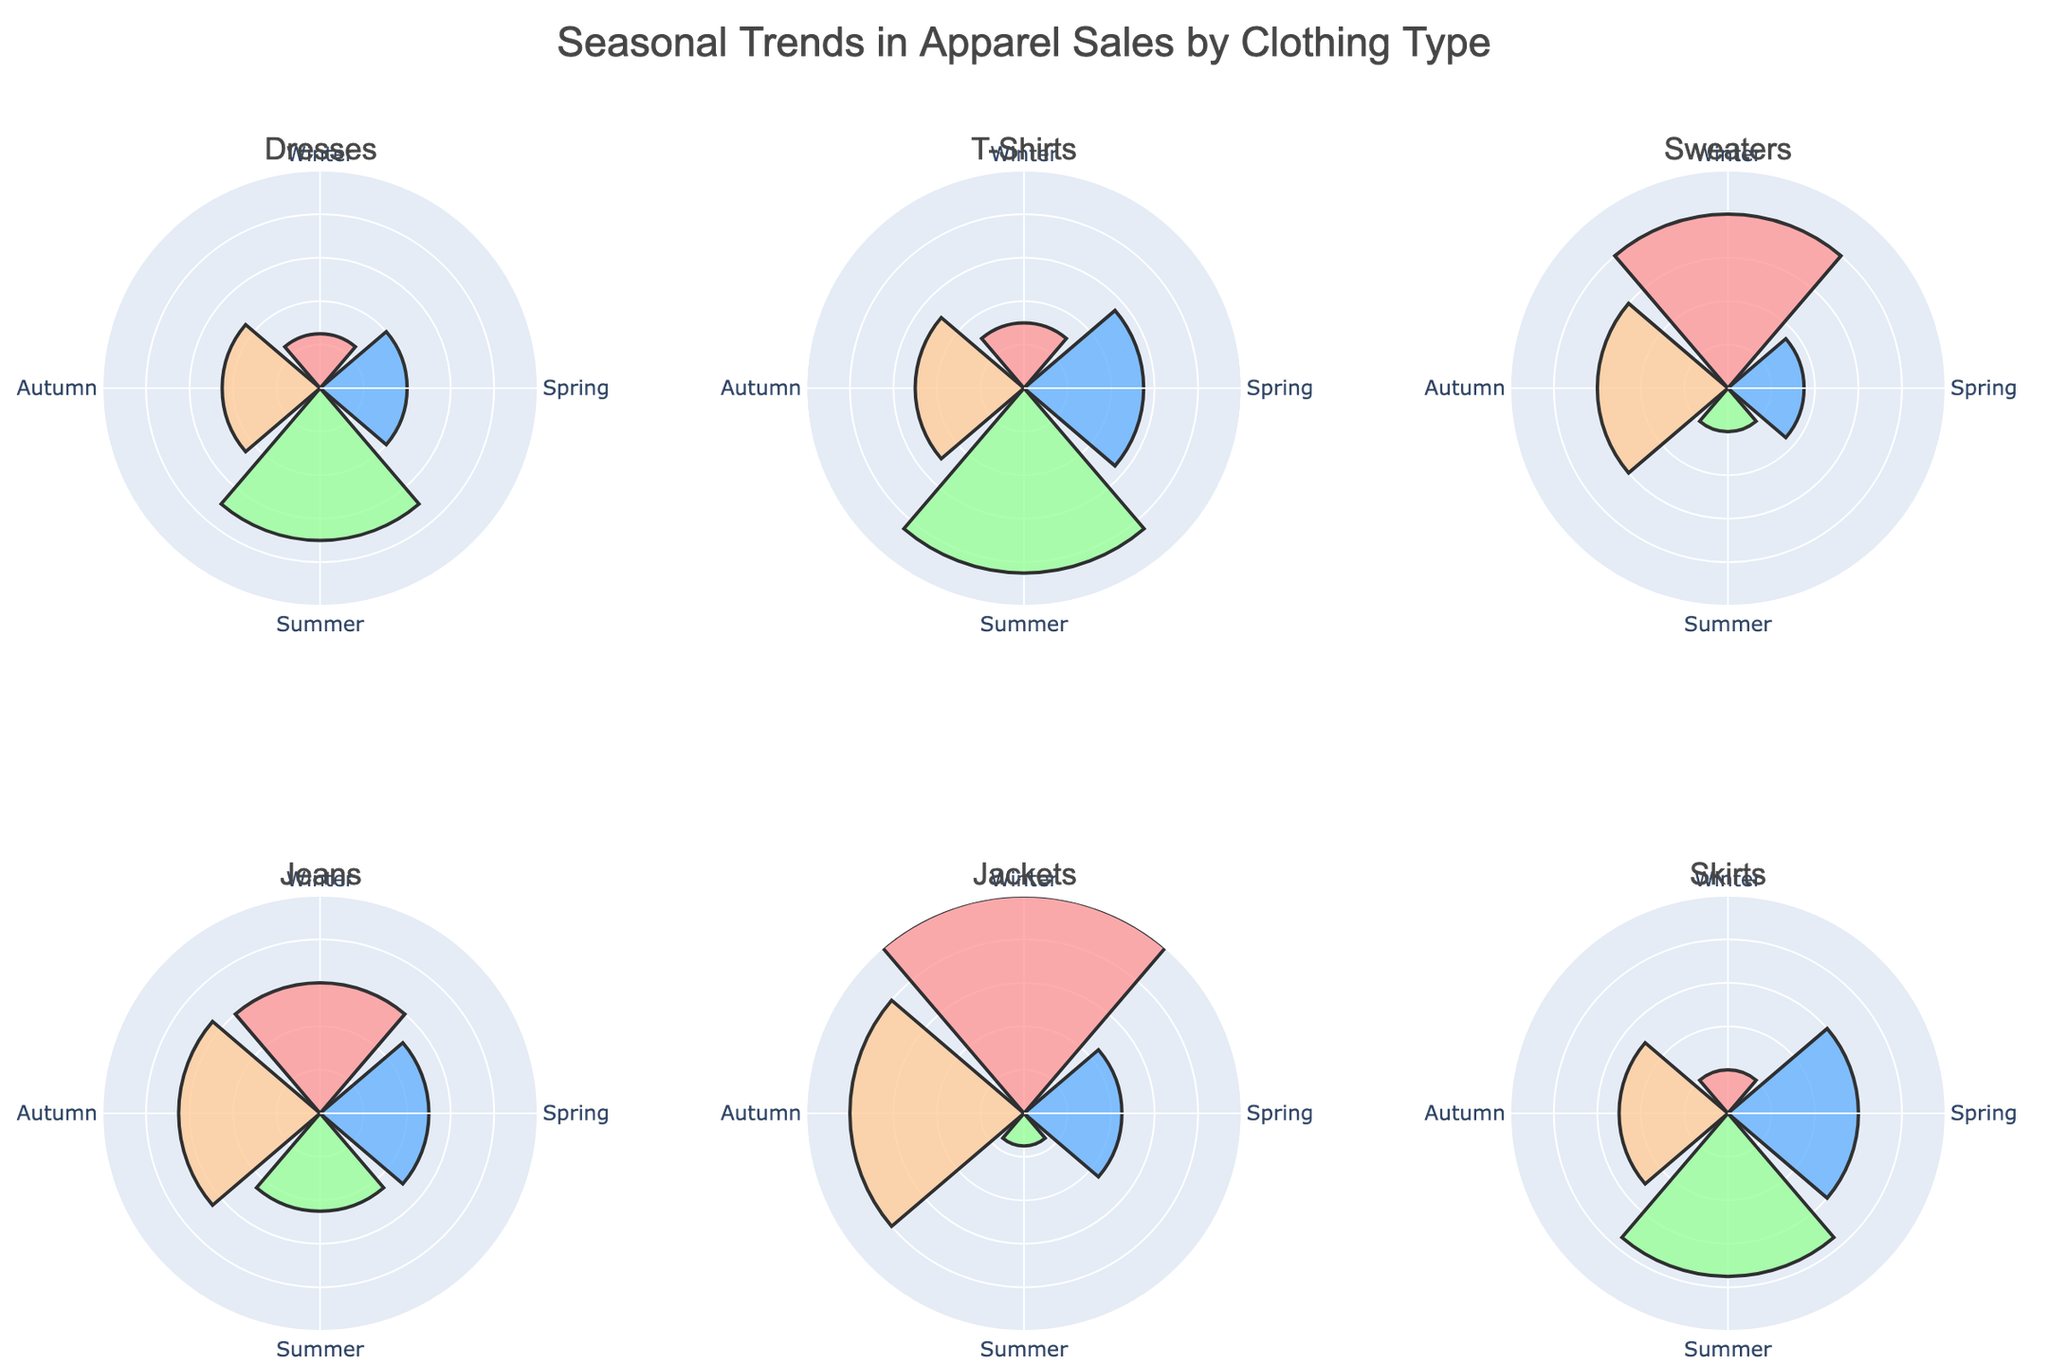What is the title of the figure? The title is usually displayed at the top of the figure. In this plot, the title provided is "Seasonal Trends in Apparel Sales by Clothing Type".
Answer: Seasonal Trends in Apparel Sales by Clothing Type How many different clothing types are displayed? The figure is made up of subplots for each clothing type. The subplot titles correspond to the number of different clothing types. By counting the subplot titles, we can see there are six: Dresses, T-Shirts, Sweaters, Jeans, Jackets, and Skirts.
Answer: Six Which clothing type has the highest sales in Winter? By examining the radial bars for each clothing type in the Winter segment of the subplots, we can see that the Jacket subplot has the highest radial value in Winter.
Answer: Jackets Which season shows the highest sales for T-Shirts? Looking at the subplot for T-Shirts, the Summer segment has the longest radial bar indicating that Summer has the highest sales for T-Shirts.
Answer: Summer What is the difference in sales between Spring and Summer for Skirts? For Skirts, identify the radial values for Spring and Summer which are 60 and 75, respectively. The difference is calculated as 75 - 60.
Answer: 15 Which season has the lowest sales for Sweaters? In the Sweaters subplot, the segment with the shortest radial bar represents the lowest sales. The Summer segment has the shortest bar.
Answer: Summer Compare Autumn sales of Jeans and Dresses. Which one has more? Observing the radial bars for Autumn in the Jeans and Dresses subplots, we can see that Jeans have a value of 65 and Dresses have 45. Therefore, Jeans have higher sales in Autumn.
Answer: Jeans What is the average sales value across all seasons for Dresses? To find the average sales value, sum the values for all seasons for Dresses (25+40+70+45) and divide by the number of seasons (4). The calculation is (25 + 40 + 70 + 45)/4 = 180/4.
Answer: 45 Which clothing type shows the most significant seasonal variation in sales? By examining each subplot, the clothing type with the greatest variation between its highest and lowest sales values indicates the most significant seasonal variation. Jackets have values ranging from 15 to 100, showing the largest variation.
Answer: Jackets 